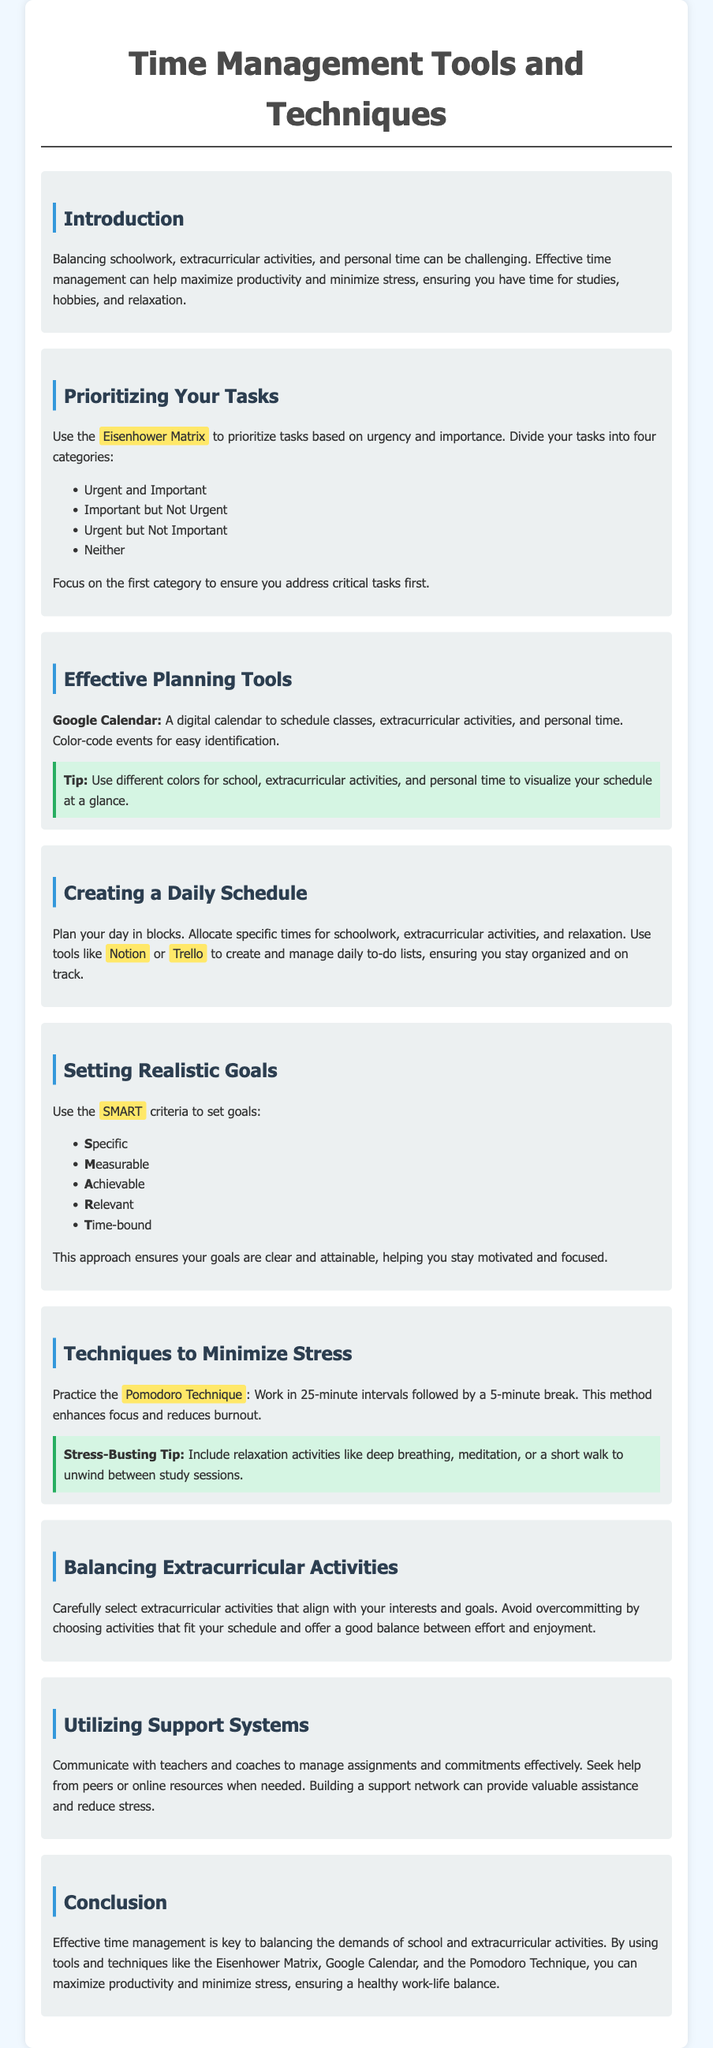What is the purpose of the guide? The guide aims to help students balance schoolwork and activities through effective time management.
Answer: Helping students balance schoolwork and activities What technique is used for prioritizing tasks? The document mentions the Eisenhower Matrix for prioritizing tasks based on urgency and importance.
Answer: Eisenhower Matrix What are the four categories of tasks in the Eisenhower Matrix? The tasks are divided into urgent and important, important but not urgent, urgent but not important, and neither.
Answer: Four categories What tools can be used to create a daily schedule? Notion and Trello are recommended for creating and managing daily to-do lists.
Answer: Notion and Trello How long are the intervals in the Pomodoro Technique? The Pomodoro Technique suggests working in intervals of 25 minutes.
Answer: 25 minutes What criteria does the SMART goal method include? The SMART criteria includes Specific, Measurable, Achievable, Relevant, and Time-bound.
Answer: Specific, Measurable, Achievable, Relevant, Time-bound What is a recommended stress-busting activity? The document suggests deep breathing, meditation, or a short walk between study sessions.
Answer: Deep breathing How should extracurricular activities be selected? Choose extracurricular activities that align with your interests and schedule to avoid overcommitting.
Answer: Align with interests and schedule 